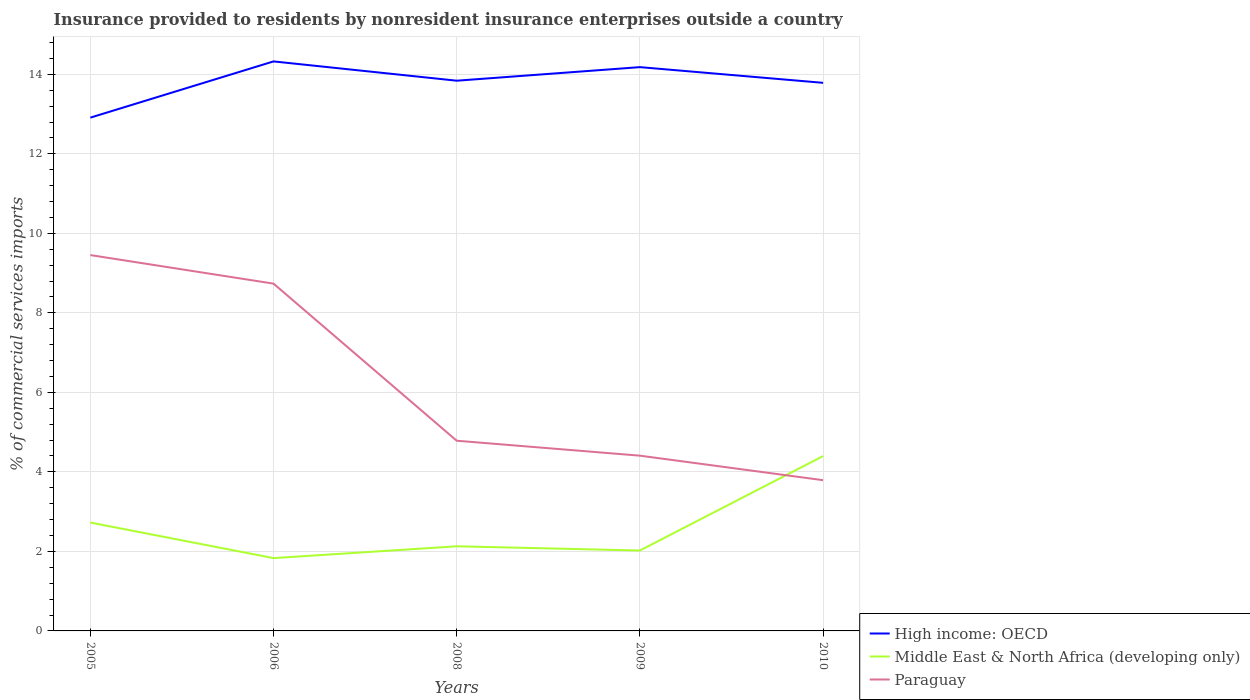How many different coloured lines are there?
Your answer should be very brief. 3. Is the number of lines equal to the number of legend labels?
Offer a very short reply. Yes. Across all years, what is the maximum Insurance provided to residents in High income: OECD?
Your answer should be compact. 12.91. What is the total Insurance provided to residents in Middle East & North Africa (developing only) in the graph?
Your answer should be very brief. 0.11. What is the difference between the highest and the second highest Insurance provided to residents in Middle East & North Africa (developing only)?
Provide a succinct answer. 2.57. How many years are there in the graph?
Keep it short and to the point. 5. Are the values on the major ticks of Y-axis written in scientific E-notation?
Give a very brief answer. No. Does the graph contain grids?
Your answer should be very brief. Yes. Where does the legend appear in the graph?
Ensure brevity in your answer.  Bottom right. How many legend labels are there?
Give a very brief answer. 3. What is the title of the graph?
Provide a succinct answer. Insurance provided to residents by nonresident insurance enterprises outside a country. Does "Bermuda" appear as one of the legend labels in the graph?
Offer a very short reply. No. What is the label or title of the Y-axis?
Your response must be concise. % of commercial services imports. What is the % of commercial services imports in High income: OECD in 2005?
Your answer should be compact. 12.91. What is the % of commercial services imports in Middle East & North Africa (developing only) in 2005?
Give a very brief answer. 2.73. What is the % of commercial services imports in Paraguay in 2005?
Provide a succinct answer. 9.45. What is the % of commercial services imports in High income: OECD in 2006?
Your answer should be compact. 14.33. What is the % of commercial services imports in Middle East & North Africa (developing only) in 2006?
Offer a very short reply. 1.83. What is the % of commercial services imports of Paraguay in 2006?
Your response must be concise. 8.74. What is the % of commercial services imports in High income: OECD in 2008?
Your answer should be compact. 13.84. What is the % of commercial services imports in Middle East & North Africa (developing only) in 2008?
Offer a terse response. 2.13. What is the % of commercial services imports of Paraguay in 2008?
Provide a short and direct response. 4.78. What is the % of commercial services imports of High income: OECD in 2009?
Provide a succinct answer. 14.18. What is the % of commercial services imports of Middle East & North Africa (developing only) in 2009?
Provide a short and direct response. 2.02. What is the % of commercial services imports of Paraguay in 2009?
Give a very brief answer. 4.41. What is the % of commercial services imports of High income: OECD in 2010?
Ensure brevity in your answer.  13.79. What is the % of commercial services imports in Middle East & North Africa (developing only) in 2010?
Provide a short and direct response. 4.4. What is the % of commercial services imports in Paraguay in 2010?
Your answer should be very brief. 3.79. Across all years, what is the maximum % of commercial services imports of High income: OECD?
Offer a very short reply. 14.33. Across all years, what is the maximum % of commercial services imports in Middle East & North Africa (developing only)?
Your response must be concise. 4.4. Across all years, what is the maximum % of commercial services imports of Paraguay?
Offer a very short reply. 9.45. Across all years, what is the minimum % of commercial services imports in High income: OECD?
Your answer should be compact. 12.91. Across all years, what is the minimum % of commercial services imports of Middle East & North Africa (developing only)?
Give a very brief answer. 1.83. Across all years, what is the minimum % of commercial services imports in Paraguay?
Your answer should be compact. 3.79. What is the total % of commercial services imports in High income: OECD in the graph?
Your response must be concise. 69.04. What is the total % of commercial services imports in Middle East & North Africa (developing only) in the graph?
Provide a short and direct response. 13.11. What is the total % of commercial services imports of Paraguay in the graph?
Your response must be concise. 31.17. What is the difference between the % of commercial services imports of High income: OECD in 2005 and that in 2006?
Your answer should be very brief. -1.41. What is the difference between the % of commercial services imports in Middle East & North Africa (developing only) in 2005 and that in 2006?
Ensure brevity in your answer.  0.89. What is the difference between the % of commercial services imports in Paraguay in 2005 and that in 2006?
Your answer should be compact. 0.72. What is the difference between the % of commercial services imports of High income: OECD in 2005 and that in 2008?
Give a very brief answer. -0.93. What is the difference between the % of commercial services imports of Middle East & North Africa (developing only) in 2005 and that in 2008?
Ensure brevity in your answer.  0.6. What is the difference between the % of commercial services imports of Paraguay in 2005 and that in 2008?
Make the answer very short. 4.67. What is the difference between the % of commercial services imports in High income: OECD in 2005 and that in 2009?
Make the answer very short. -1.27. What is the difference between the % of commercial services imports in Middle East & North Africa (developing only) in 2005 and that in 2009?
Offer a very short reply. 0.7. What is the difference between the % of commercial services imports of Paraguay in 2005 and that in 2009?
Offer a terse response. 5.05. What is the difference between the % of commercial services imports of High income: OECD in 2005 and that in 2010?
Keep it short and to the point. -0.88. What is the difference between the % of commercial services imports in Middle East & North Africa (developing only) in 2005 and that in 2010?
Your response must be concise. -1.67. What is the difference between the % of commercial services imports in Paraguay in 2005 and that in 2010?
Provide a short and direct response. 5.66. What is the difference between the % of commercial services imports of High income: OECD in 2006 and that in 2008?
Ensure brevity in your answer.  0.49. What is the difference between the % of commercial services imports of Middle East & North Africa (developing only) in 2006 and that in 2008?
Provide a succinct answer. -0.3. What is the difference between the % of commercial services imports of Paraguay in 2006 and that in 2008?
Your response must be concise. 3.95. What is the difference between the % of commercial services imports of High income: OECD in 2006 and that in 2009?
Your answer should be compact. 0.14. What is the difference between the % of commercial services imports in Middle East & North Africa (developing only) in 2006 and that in 2009?
Offer a very short reply. -0.19. What is the difference between the % of commercial services imports of Paraguay in 2006 and that in 2009?
Provide a succinct answer. 4.33. What is the difference between the % of commercial services imports of High income: OECD in 2006 and that in 2010?
Provide a succinct answer. 0.54. What is the difference between the % of commercial services imports of Middle East & North Africa (developing only) in 2006 and that in 2010?
Provide a succinct answer. -2.57. What is the difference between the % of commercial services imports of Paraguay in 2006 and that in 2010?
Your answer should be very brief. 4.94. What is the difference between the % of commercial services imports in High income: OECD in 2008 and that in 2009?
Give a very brief answer. -0.34. What is the difference between the % of commercial services imports of Middle East & North Africa (developing only) in 2008 and that in 2009?
Provide a short and direct response. 0.11. What is the difference between the % of commercial services imports in Paraguay in 2008 and that in 2009?
Keep it short and to the point. 0.38. What is the difference between the % of commercial services imports in High income: OECD in 2008 and that in 2010?
Your response must be concise. 0.05. What is the difference between the % of commercial services imports of Middle East & North Africa (developing only) in 2008 and that in 2010?
Make the answer very short. -2.27. What is the difference between the % of commercial services imports of Paraguay in 2008 and that in 2010?
Provide a succinct answer. 0.99. What is the difference between the % of commercial services imports in High income: OECD in 2009 and that in 2010?
Make the answer very short. 0.39. What is the difference between the % of commercial services imports of Middle East & North Africa (developing only) in 2009 and that in 2010?
Provide a short and direct response. -2.38. What is the difference between the % of commercial services imports in Paraguay in 2009 and that in 2010?
Your answer should be compact. 0.62. What is the difference between the % of commercial services imports of High income: OECD in 2005 and the % of commercial services imports of Middle East & North Africa (developing only) in 2006?
Offer a very short reply. 11.08. What is the difference between the % of commercial services imports of High income: OECD in 2005 and the % of commercial services imports of Paraguay in 2006?
Ensure brevity in your answer.  4.18. What is the difference between the % of commercial services imports in Middle East & North Africa (developing only) in 2005 and the % of commercial services imports in Paraguay in 2006?
Your response must be concise. -6.01. What is the difference between the % of commercial services imports of High income: OECD in 2005 and the % of commercial services imports of Middle East & North Africa (developing only) in 2008?
Offer a very short reply. 10.78. What is the difference between the % of commercial services imports of High income: OECD in 2005 and the % of commercial services imports of Paraguay in 2008?
Your response must be concise. 8.13. What is the difference between the % of commercial services imports in Middle East & North Africa (developing only) in 2005 and the % of commercial services imports in Paraguay in 2008?
Your answer should be compact. -2.06. What is the difference between the % of commercial services imports in High income: OECD in 2005 and the % of commercial services imports in Middle East & North Africa (developing only) in 2009?
Provide a short and direct response. 10.89. What is the difference between the % of commercial services imports in High income: OECD in 2005 and the % of commercial services imports in Paraguay in 2009?
Give a very brief answer. 8.5. What is the difference between the % of commercial services imports of Middle East & North Africa (developing only) in 2005 and the % of commercial services imports of Paraguay in 2009?
Your answer should be very brief. -1.68. What is the difference between the % of commercial services imports of High income: OECD in 2005 and the % of commercial services imports of Middle East & North Africa (developing only) in 2010?
Ensure brevity in your answer.  8.51. What is the difference between the % of commercial services imports of High income: OECD in 2005 and the % of commercial services imports of Paraguay in 2010?
Your answer should be compact. 9.12. What is the difference between the % of commercial services imports of Middle East & North Africa (developing only) in 2005 and the % of commercial services imports of Paraguay in 2010?
Make the answer very short. -1.07. What is the difference between the % of commercial services imports of High income: OECD in 2006 and the % of commercial services imports of Middle East & North Africa (developing only) in 2008?
Your answer should be compact. 12.2. What is the difference between the % of commercial services imports of High income: OECD in 2006 and the % of commercial services imports of Paraguay in 2008?
Give a very brief answer. 9.54. What is the difference between the % of commercial services imports of Middle East & North Africa (developing only) in 2006 and the % of commercial services imports of Paraguay in 2008?
Offer a very short reply. -2.95. What is the difference between the % of commercial services imports of High income: OECD in 2006 and the % of commercial services imports of Middle East & North Africa (developing only) in 2009?
Provide a short and direct response. 12.3. What is the difference between the % of commercial services imports of High income: OECD in 2006 and the % of commercial services imports of Paraguay in 2009?
Your answer should be very brief. 9.92. What is the difference between the % of commercial services imports of Middle East & North Africa (developing only) in 2006 and the % of commercial services imports of Paraguay in 2009?
Offer a very short reply. -2.58. What is the difference between the % of commercial services imports in High income: OECD in 2006 and the % of commercial services imports in Middle East & North Africa (developing only) in 2010?
Ensure brevity in your answer.  9.93. What is the difference between the % of commercial services imports in High income: OECD in 2006 and the % of commercial services imports in Paraguay in 2010?
Your answer should be very brief. 10.53. What is the difference between the % of commercial services imports of Middle East & North Africa (developing only) in 2006 and the % of commercial services imports of Paraguay in 2010?
Provide a short and direct response. -1.96. What is the difference between the % of commercial services imports in High income: OECD in 2008 and the % of commercial services imports in Middle East & North Africa (developing only) in 2009?
Provide a succinct answer. 11.82. What is the difference between the % of commercial services imports of High income: OECD in 2008 and the % of commercial services imports of Paraguay in 2009?
Provide a short and direct response. 9.43. What is the difference between the % of commercial services imports of Middle East & North Africa (developing only) in 2008 and the % of commercial services imports of Paraguay in 2009?
Give a very brief answer. -2.28. What is the difference between the % of commercial services imports in High income: OECD in 2008 and the % of commercial services imports in Middle East & North Africa (developing only) in 2010?
Provide a short and direct response. 9.44. What is the difference between the % of commercial services imports in High income: OECD in 2008 and the % of commercial services imports in Paraguay in 2010?
Keep it short and to the point. 10.05. What is the difference between the % of commercial services imports in Middle East & North Africa (developing only) in 2008 and the % of commercial services imports in Paraguay in 2010?
Your response must be concise. -1.66. What is the difference between the % of commercial services imports of High income: OECD in 2009 and the % of commercial services imports of Middle East & North Africa (developing only) in 2010?
Offer a very short reply. 9.78. What is the difference between the % of commercial services imports of High income: OECD in 2009 and the % of commercial services imports of Paraguay in 2010?
Offer a very short reply. 10.39. What is the difference between the % of commercial services imports in Middle East & North Africa (developing only) in 2009 and the % of commercial services imports in Paraguay in 2010?
Keep it short and to the point. -1.77. What is the average % of commercial services imports in High income: OECD per year?
Your answer should be compact. 13.81. What is the average % of commercial services imports of Middle East & North Africa (developing only) per year?
Ensure brevity in your answer.  2.62. What is the average % of commercial services imports in Paraguay per year?
Offer a very short reply. 6.23. In the year 2005, what is the difference between the % of commercial services imports of High income: OECD and % of commercial services imports of Middle East & North Africa (developing only)?
Give a very brief answer. 10.19. In the year 2005, what is the difference between the % of commercial services imports in High income: OECD and % of commercial services imports in Paraguay?
Your answer should be very brief. 3.46. In the year 2005, what is the difference between the % of commercial services imports in Middle East & North Africa (developing only) and % of commercial services imports in Paraguay?
Your response must be concise. -6.73. In the year 2006, what is the difference between the % of commercial services imports in High income: OECD and % of commercial services imports in Middle East & North Africa (developing only)?
Your answer should be very brief. 12.49. In the year 2006, what is the difference between the % of commercial services imports of High income: OECD and % of commercial services imports of Paraguay?
Give a very brief answer. 5.59. In the year 2006, what is the difference between the % of commercial services imports of Middle East & North Africa (developing only) and % of commercial services imports of Paraguay?
Your response must be concise. -6.9. In the year 2008, what is the difference between the % of commercial services imports of High income: OECD and % of commercial services imports of Middle East & North Africa (developing only)?
Your answer should be compact. 11.71. In the year 2008, what is the difference between the % of commercial services imports of High income: OECD and % of commercial services imports of Paraguay?
Provide a succinct answer. 9.06. In the year 2008, what is the difference between the % of commercial services imports in Middle East & North Africa (developing only) and % of commercial services imports in Paraguay?
Keep it short and to the point. -2.66. In the year 2009, what is the difference between the % of commercial services imports in High income: OECD and % of commercial services imports in Middle East & North Africa (developing only)?
Ensure brevity in your answer.  12.16. In the year 2009, what is the difference between the % of commercial services imports of High income: OECD and % of commercial services imports of Paraguay?
Offer a very short reply. 9.77. In the year 2009, what is the difference between the % of commercial services imports in Middle East & North Africa (developing only) and % of commercial services imports in Paraguay?
Your response must be concise. -2.39. In the year 2010, what is the difference between the % of commercial services imports of High income: OECD and % of commercial services imports of Middle East & North Africa (developing only)?
Offer a terse response. 9.39. In the year 2010, what is the difference between the % of commercial services imports of High income: OECD and % of commercial services imports of Paraguay?
Ensure brevity in your answer.  9.99. In the year 2010, what is the difference between the % of commercial services imports of Middle East & North Africa (developing only) and % of commercial services imports of Paraguay?
Keep it short and to the point. 0.61. What is the ratio of the % of commercial services imports in High income: OECD in 2005 to that in 2006?
Provide a succinct answer. 0.9. What is the ratio of the % of commercial services imports of Middle East & North Africa (developing only) in 2005 to that in 2006?
Keep it short and to the point. 1.49. What is the ratio of the % of commercial services imports of Paraguay in 2005 to that in 2006?
Ensure brevity in your answer.  1.08. What is the ratio of the % of commercial services imports of High income: OECD in 2005 to that in 2008?
Offer a terse response. 0.93. What is the ratio of the % of commercial services imports of Middle East & North Africa (developing only) in 2005 to that in 2008?
Provide a succinct answer. 1.28. What is the ratio of the % of commercial services imports of Paraguay in 2005 to that in 2008?
Keep it short and to the point. 1.98. What is the ratio of the % of commercial services imports in High income: OECD in 2005 to that in 2009?
Give a very brief answer. 0.91. What is the ratio of the % of commercial services imports of Middle East & North Africa (developing only) in 2005 to that in 2009?
Offer a very short reply. 1.35. What is the ratio of the % of commercial services imports of Paraguay in 2005 to that in 2009?
Provide a succinct answer. 2.14. What is the ratio of the % of commercial services imports in High income: OECD in 2005 to that in 2010?
Your response must be concise. 0.94. What is the ratio of the % of commercial services imports in Middle East & North Africa (developing only) in 2005 to that in 2010?
Offer a very short reply. 0.62. What is the ratio of the % of commercial services imports of Paraguay in 2005 to that in 2010?
Your answer should be compact. 2.49. What is the ratio of the % of commercial services imports in High income: OECD in 2006 to that in 2008?
Keep it short and to the point. 1.04. What is the ratio of the % of commercial services imports in Middle East & North Africa (developing only) in 2006 to that in 2008?
Provide a short and direct response. 0.86. What is the ratio of the % of commercial services imports of Paraguay in 2006 to that in 2008?
Your response must be concise. 1.83. What is the ratio of the % of commercial services imports of High income: OECD in 2006 to that in 2009?
Keep it short and to the point. 1.01. What is the ratio of the % of commercial services imports in Middle East & North Africa (developing only) in 2006 to that in 2009?
Offer a very short reply. 0.91. What is the ratio of the % of commercial services imports of Paraguay in 2006 to that in 2009?
Offer a very short reply. 1.98. What is the ratio of the % of commercial services imports in High income: OECD in 2006 to that in 2010?
Offer a terse response. 1.04. What is the ratio of the % of commercial services imports of Middle East & North Africa (developing only) in 2006 to that in 2010?
Your answer should be compact. 0.42. What is the ratio of the % of commercial services imports in Paraguay in 2006 to that in 2010?
Offer a very short reply. 2.3. What is the ratio of the % of commercial services imports in High income: OECD in 2008 to that in 2009?
Make the answer very short. 0.98. What is the ratio of the % of commercial services imports in Middle East & North Africa (developing only) in 2008 to that in 2009?
Make the answer very short. 1.05. What is the ratio of the % of commercial services imports in Paraguay in 2008 to that in 2009?
Offer a very short reply. 1.09. What is the ratio of the % of commercial services imports of High income: OECD in 2008 to that in 2010?
Your response must be concise. 1. What is the ratio of the % of commercial services imports in Middle East & North Africa (developing only) in 2008 to that in 2010?
Offer a terse response. 0.48. What is the ratio of the % of commercial services imports in Paraguay in 2008 to that in 2010?
Your answer should be compact. 1.26. What is the ratio of the % of commercial services imports in High income: OECD in 2009 to that in 2010?
Offer a very short reply. 1.03. What is the ratio of the % of commercial services imports of Middle East & North Africa (developing only) in 2009 to that in 2010?
Keep it short and to the point. 0.46. What is the ratio of the % of commercial services imports in Paraguay in 2009 to that in 2010?
Offer a very short reply. 1.16. What is the difference between the highest and the second highest % of commercial services imports of High income: OECD?
Offer a terse response. 0.14. What is the difference between the highest and the second highest % of commercial services imports of Middle East & North Africa (developing only)?
Provide a succinct answer. 1.67. What is the difference between the highest and the second highest % of commercial services imports of Paraguay?
Your answer should be very brief. 0.72. What is the difference between the highest and the lowest % of commercial services imports in High income: OECD?
Make the answer very short. 1.41. What is the difference between the highest and the lowest % of commercial services imports of Middle East & North Africa (developing only)?
Your answer should be compact. 2.57. What is the difference between the highest and the lowest % of commercial services imports of Paraguay?
Your response must be concise. 5.66. 